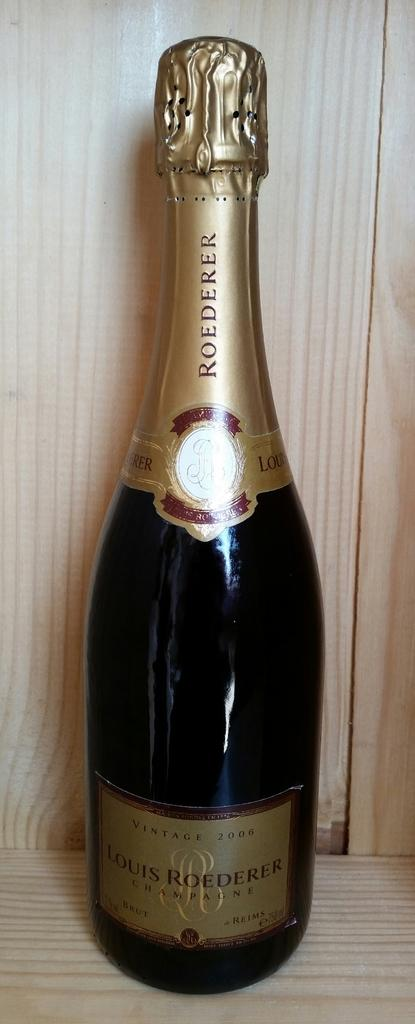<image>
Present a compact description of the photo's key features. A vintage 2006 bottle of champagne sits in a wooden box. 